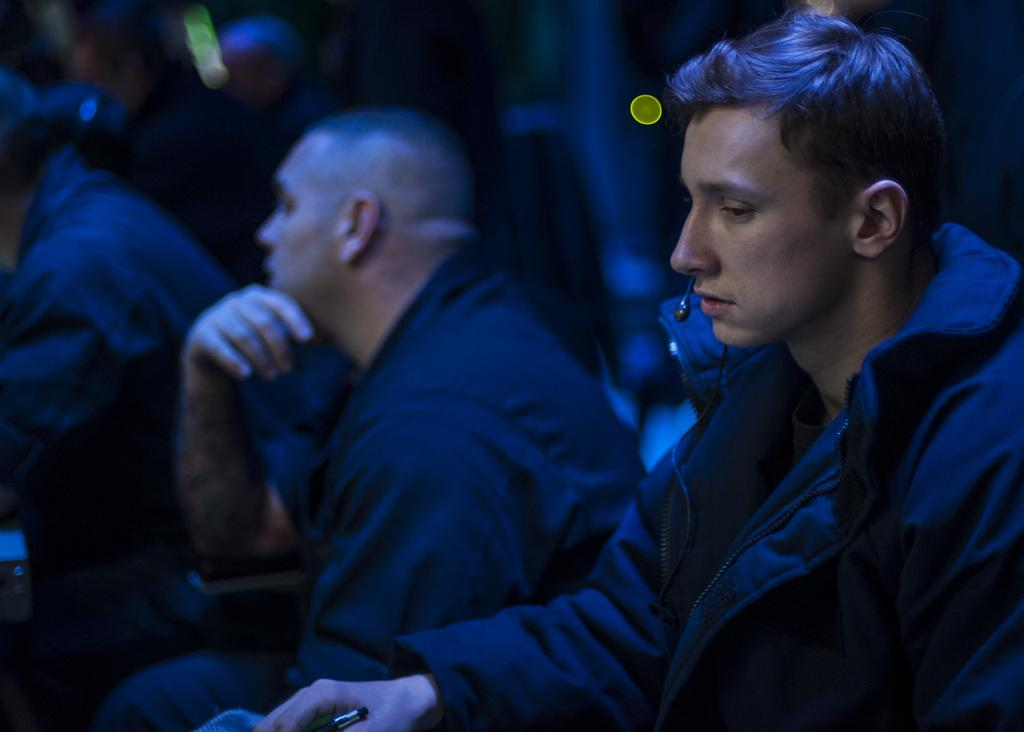What are the people in the image doing? The people in the image are sitting. Can you describe what one of the people is holding? Yes, there is a person holding an object in the image. What can be observed about the lighting in the image? The background of the image is dark. What type of toys can be seen in the image? There are no toys present in the image. Can you describe the detailed pattern on the person's shirt in the image? The provided facts do not mention any specific patterns or details on the person's clothing. --- 